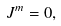<formula> <loc_0><loc_0><loc_500><loc_500>J ^ { m } = 0 ,</formula> 